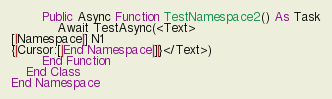Convert code to text. <code><loc_0><loc_0><loc_500><loc_500><_VisualBasic_>        Public Async Function TestNamespace2() As Task
            Await TestAsync(<Text>
[|Namespace|] N1
{|Cursor:[|End Namespace|]|}</Text>)
        End Function
    End Class
End Namespace
</code> 